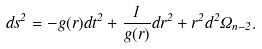Convert formula to latex. <formula><loc_0><loc_0><loc_500><loc_500>d s ^ { 2 } = - g ( r ) d t ^ { 2 } + \frac { 1 } { g ( r ) } d r ^ { 2 } + r ^ { 2 } d ^ { 2 } \Omega _ { n - 2 } .</formula> 